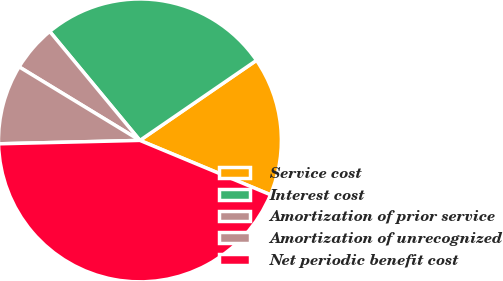Convert chart. <chart><loc_0><loc_0><loc_500><loc_500><pie_chart><fcel>Service cost<fcel>Interest cost<fcel>Amortization of prior service<fcel>Amortization of unrecognized<fcel>Net periodic benefit cost<nl><fcel>15.86%<fcel>26.43%<fcel>5.29%<fcel>9.09%<fcel>43.34%<nl></chart> 